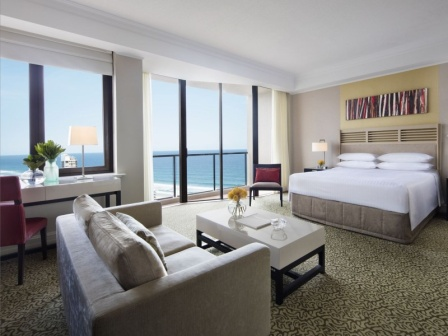Can you tell me about the design style of the furniture in this room? The furniture in the room features a contemporary design style, characterized by clean lines and a neutral color palette. The grey sofa and armchair provide a modern touch, complemented by the simple yet elegant white coffee table. These pieces combine functionality with aesthetic appeal, adhering to a minimalist yet cozy design philosophy. 